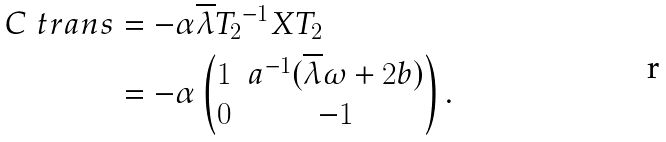Convert formula to latex. <formula><loc_0><loc_0><loc_500><loc_500>C \ t r a n s & = - \alpha \overline { \lambda } { T _ { 2 } } ^ { - 1 } X T _ { 2 } \\ & = - \alpha \begin{pmatrix} 1 & a ^ { - 1 } ( \overline { \lambda } \omega + 2 b ) \\ 0 & - 1 \end{pmatrix} .</formula> 